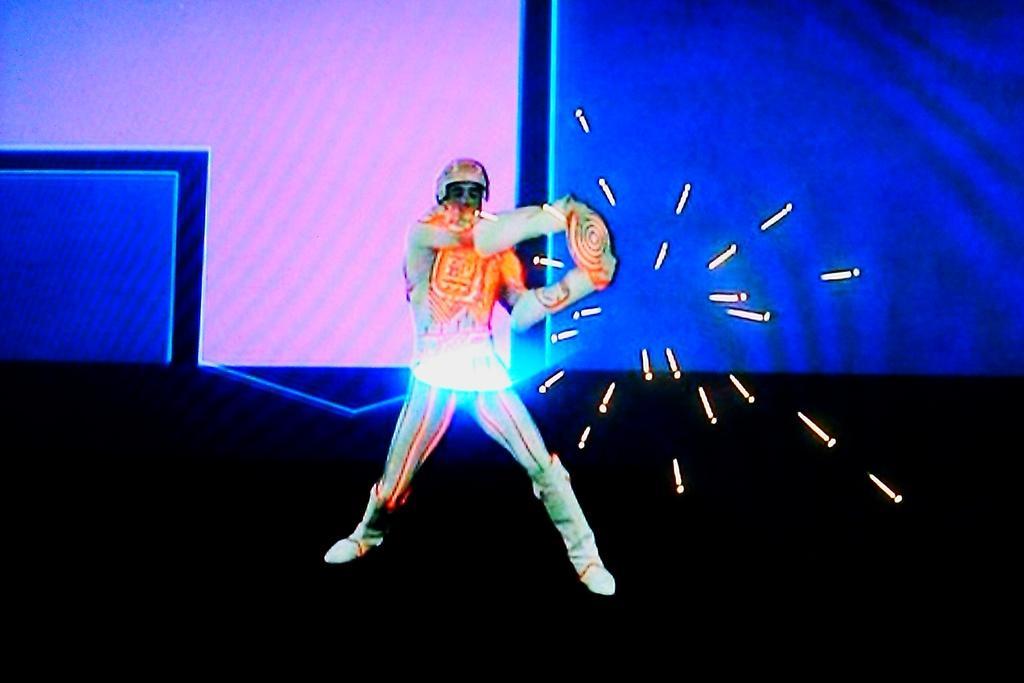Can you describe this image briefly? In this image in the center there is one person who is wearing a costume, and he is holding something and also there is some light. In the background there is screen and the bottom is black color. 